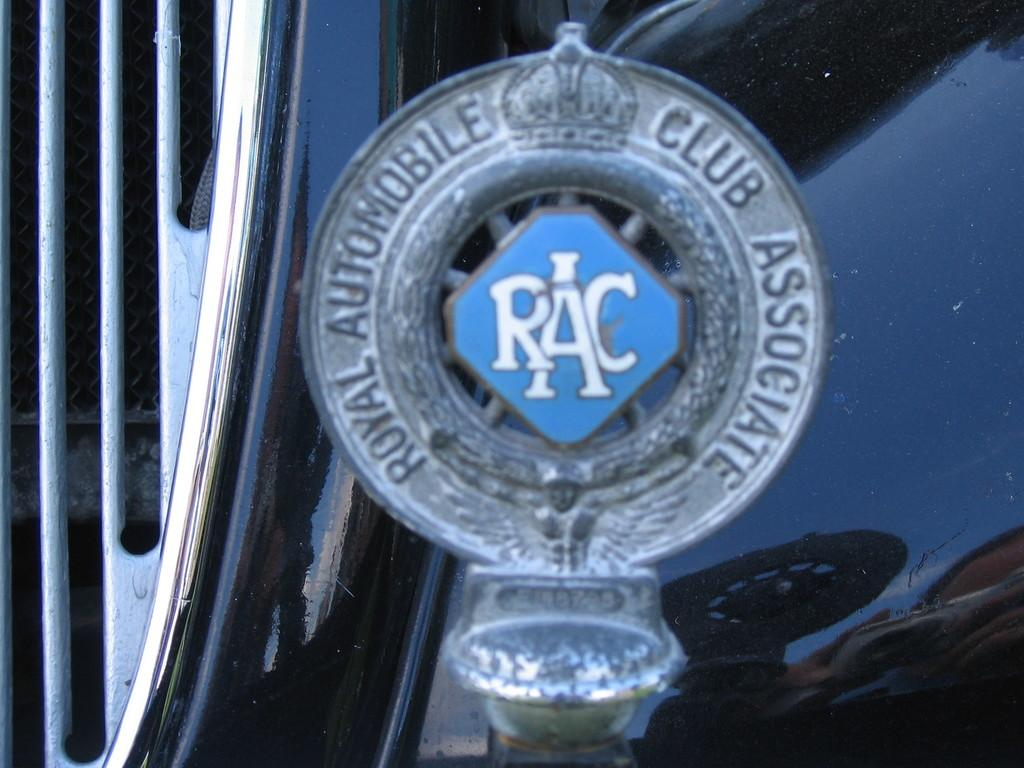What is the main subject of the image? The main subject of the image is a car logo. What can be seen on the car logo? There is text on the car logo. What part of a car is visible behind the logo? The bonnet of a car is visible behind the logo. Can you see a zipper on the car logo in the image? No, there is no zipper present on the car logo in the image. What type of glass is used to make the car logo in the image? There is no glass used to make the car logo in the image; it is likely made of a different material, such as metal or plastic. 